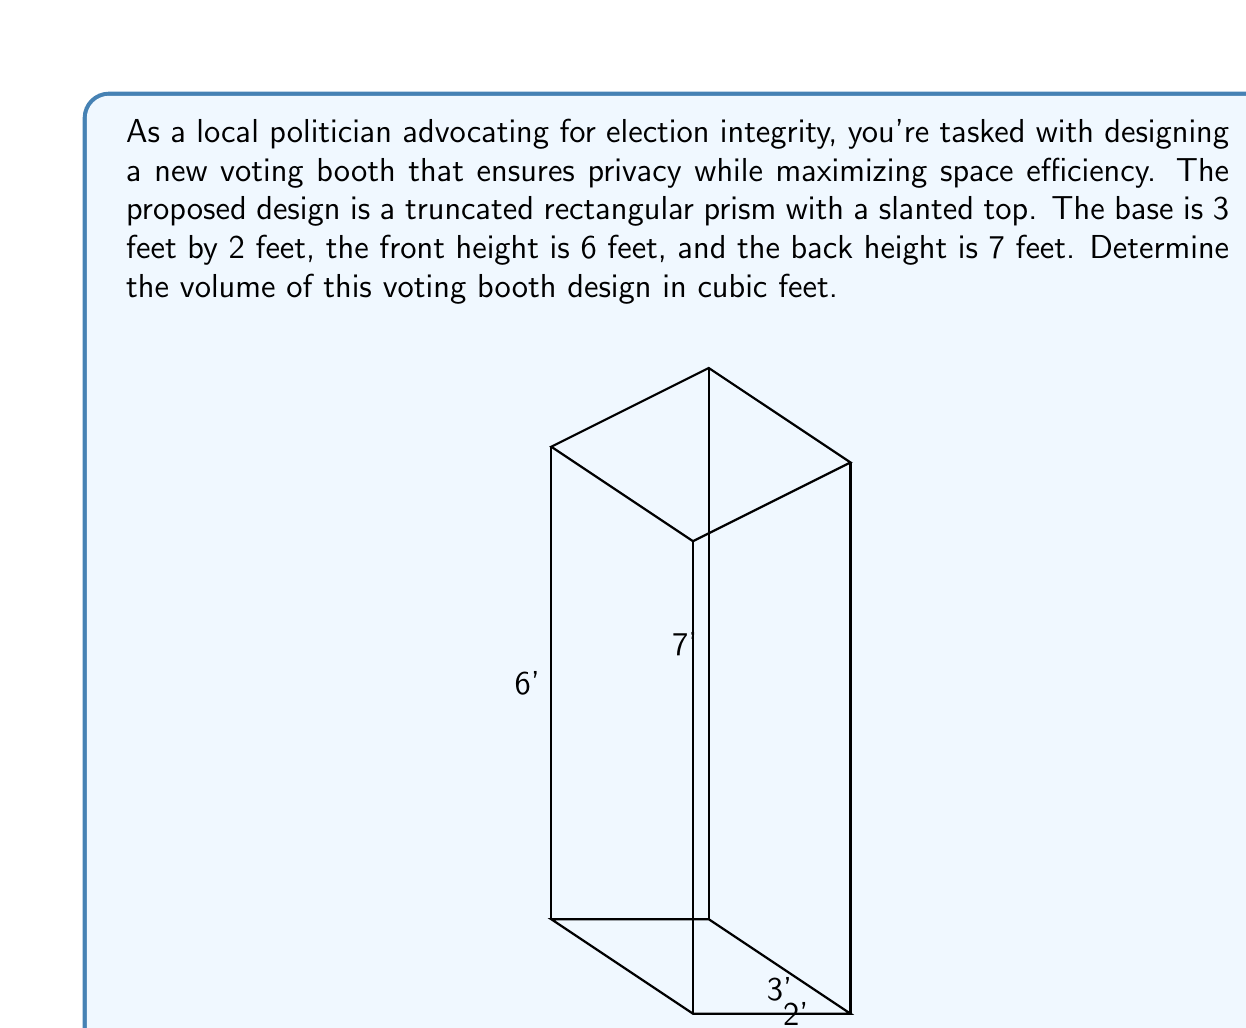Can you answer this question? To calculate the volume of this truncated rectangular prism, we can use the formula for the volume of a prism with a non-parallel top:

$$V = \frac{1}{2}(h_1 + h_2)A$$

Where:
$V$ is the volume
$h_1$ is the height at the front (6 feet)
$h_2$ is the height at the back (7 feet)
$A$ is the area of the base

Steps:
1) Calculate the area of the base:
   $A = 3 \text{ ft} \times 2 \text{ ft} = 6 \text{ ft}^2$

2) Apply the formula:
   $$V = \frac{1}{2}(6 \text{ ft} + 7 \text{ ft}) \times 6 \text{ ft}^2$$
   $$V = \frac{1}{2}(13 \text{ ft}) \times 6 \text{ ft}^2$$
   $$V = 6.5 \text{ ft} \times 6 \text{ ft}^2$$
   $$V = 39 \text{ ft}^3$$

Therefore, the volume of the voting booth is 39 cubic feet.
Answer: 39 ft³ 